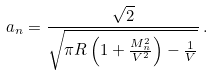Convert formula to latex. <formula><loc_0><loc_0><loc_500><loc_500>\ a _ { n } = \frac { \sqrt { 2 } } { \sqrt { \pi R \left ( 1 + \frac { M _ { n } ^ { 2 } } { V ^ { 2 } } \right ) - \frac { 1 } { V } } } \, .</formula> 